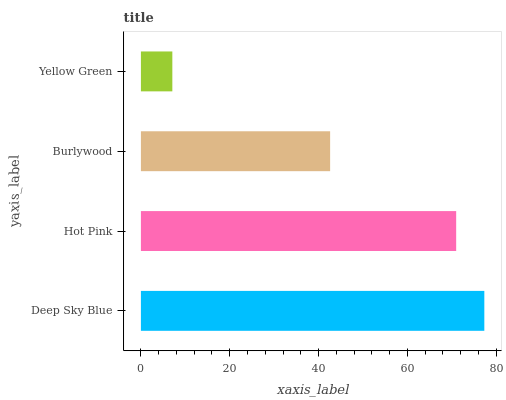Is Yellow Green the minimum?
Answer yes or no. Yes. Is Deep Sky Blue the maximum?
Answer yes or no. Yes. Is Hot Pink the minimum?
Answer yes or no. No. Is Hot Pink the maximum?
Answer yes or no. No. Is Deep Sky Blue greater than Hot Pink?
Answer yes or no. Yes. Is Hot Pink less than Deep Sky Blue?
Answer yes or no. Yes. Is Hot Pink greater than Deep Sky Blue?
Answer yes or no. No. Is Deep Sky Blue less than Hot Pink?
Answer yes or no. No. Is Hot Pink the high median?
Answer yes or no. Yes. Is Burlywood the low median?
Answer yes or no. Yes. Is Deep Sky Blue the high median?
Answer yes or no. No. Is Deep Sky Blue the low median?
Answer yes or no. No. 